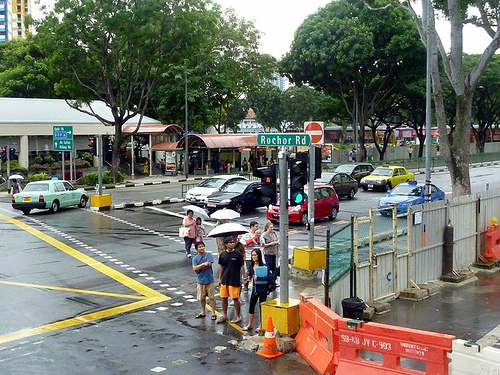<image>
Is the person to the left of the traffic cone? Yes. From this viewpoint, the person is positioned to the left side relative to the traffic cone. Where is the man in relation to the girl? Is it to the left of the girl? Yes. From this viewpoint, the man is positioned to the left side relative to the girl. 